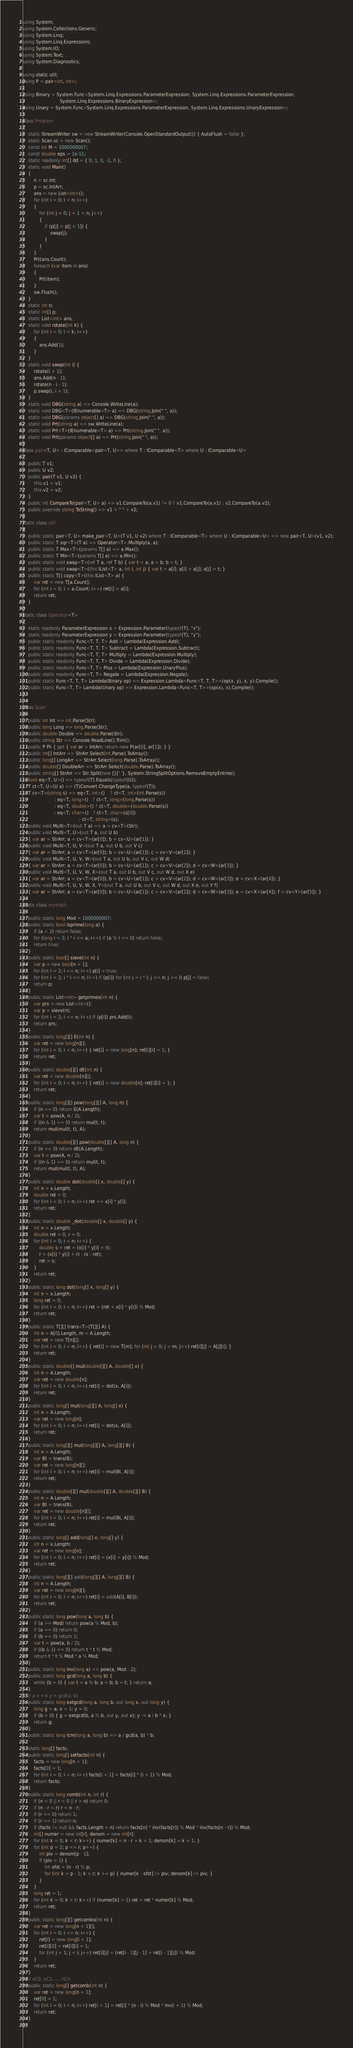Convert code to text. <code><loc_0><loc_0><loc_500><loc_500><_C#_>using System;
using System.Collections.Generic;
using System.Linq;
using System.Linq.Expressions;
using System.IO;
using System.Text;
using System.Diagnostics;

using static util;
using P = pair<int, int>;

using Binary = System.Func<System.Linq.Expressions.ParameterExpression, System.Linq.Expressions.ParameterExpression,
                           System.Linq.Expressions.BinaryExpression>;
using Unary = System.Func<System.Linq.Expressions.ParameterExpression, System.Linq.Expressions.UnaryExpression>;

class Program
{
    static StreamWriter sw = new StreamWriter(Console.OpenStandardOutput()) { AutoFlush = false };
    static Scan sc = new Scan();
    const int M = 1000000007;
    const double eps = 1e-11;
    static readonly int[] dd = { 0, 1, 0, -1, 0 };
    static void Main()
    {
        n = sc.Int;
        p = sc.IntArr;
        ans = new List<int>();
        for (int i = 0; i < n; i++)
        {
            for (int j = 0; j + 1 < n; j++)
            {
                if (p[j] > p[j + 1]) {
                    swap(j);
                }
            }
        }
        Prt(ans.Count);
        foreach (var item in ans)
        {
            Prt(item);
        }
        sw.Flush();
    }
    static int n;
    static int[] p;
    static List<int> ans;
    static void rotate(int k) {
        for (int i = 0; i < k; i++)
        {
            ans.Add(1);
        }
    }
    static void swap(int i) {
        rotate(i + 1);
        ans.Add(n - 1);
        rotate(n - i - 1);
        p.swap(i, i + 1);
    }
    static void DBG(string a) => Console.WriteLine(a);
    static void DBG<T>(IEnumerable<T> a) => DBG(string.Join(" ", a));
    static void DBG(params object[] a) => DBG(string.Join(" ", a));
    static void Prt(string a) => sw.WriteLine(a);
    static void Prt<T>(IEnumerable<T> a) => Prt(string.Join(" ", a));
    static void Prt(params object[] a) => Prt(string.Join(" ", a));
}
class pair<T, U> : IComparable<pair<T, U>> where T : IComparable<T> where U : IComparable<U>
{
    public T v1;
    public U v2;
    public pair(T v1, U v2) {
        this.v1 = v1;
        this.v2 = v2;
    }
    public int CompareTo(pair<T, U> a) => v1.CompareTo(a.v1) != 0 ? v1.CompareTo(a.v1) : v2.CompareTo(a.v2);
    public override string ToString() => v1 + " " + v2;
}
static class util
{
    public static pair<T, U> make_pair<T, U>(T v1, U v2) where T : IComparable<T> where U : IComparable<U> => new pair<T, U>(v1, v2);
    public static T sqr<T>(T a) => Operator<T>.Multiply(a, a);
    public static T Max<T>(params T[] a) => a.Max();
    public static T Min<T>(params T[] a) => a.Min();
    public static void swap<T>(ref T a, ref T b) { var t = a; a = b; b = t; }
    public static void swap<T>(this IList<T> a, int i, int j) { var t = a[i]; a[i] = a[j]; a[j] = t; }
    public static T[] copy<T>(this IList<T> a) {
        var ret = new T[a.Count];
        for (int i = 0; i < a.Count; i++) ret[i] = a[i];
        return ret;
    }
}
static class Operator<T>
{
    static readonly ParameterExpression x = Expression.Parameter(typeof(T), "x");
    static readonly ParameterExpression y = Expression.Parameter(typeof(T), "y");
    public static readonly Func<T, T, T> Add = Lambda(Expression.Add);
    public static readonly Func<T, T, T> Subtract = Lambda(Expression.Subtract);
    public static readonly Func<T, T, T> Multiply = Lambda(Expression.Multiply);
    public static readonly Func<T, T, T> Divide = Lambda(Expression.Divide);
    public static readonly Func<T, T> Plus = Lambda(Expression.UnaryPlus);
    public static readonly Func<T, T> Negate = Lambda(Expression.Negate);
    public static Func<T, T, T> Lambda(Binary op) => Expression.Lambda<Func<T, T, T>>(op(x, y), x, y).Compile();
    public static Func<T, T> Lambda(Unary op) => Expression.Lambda<Func<T, T>>(op(x), x).Compile();
}

class Scan
{
    public int Int => int.Parse(Str);
    public long Long => long.Parse(Str);
    public double Double => double.Parse(Str);
    public string Str => Console.ReadLine().Trim();
    public P Pii { get { var ar = IntArr; return new P(ar[0], ar[1]); } }
    public int[] IntArr => StrArr.Select(int.Parse).ToArray();
    public long[] LongArr => StrArr.Select(long.Parse).ToArray();
    public double[] DoubleArr => StrArr.Select(double.Parse).ToArray();
    public string[] StrArr => Str.Split(new []{' '}, System.StringSplitOptions.RemoveEmptyEntries);
    bool eq<T, U>() => typeof(T).Equals(typeof(U));
    T ct<T, U>(U a) => (T)Convert.ChangeType(a, typeof(T));
    T cv<T>(string s) => eq<T, int>()    ? ct<T, int>(int.Parse(s))
                       : eq<T, long>()   ? ct<T, long>(long.Parse(s))
                       : eq<T, double>() ? ct<T, double>(double.Parse(s))
                       : eq<T, char>()   ? ct<T, char>(s[0])
                                         : ct<T, string>(s);
    public void Multi<T>(out T a) => a = cv<T>(Str);
    public void Multi<T, U>(out T a, out U b)
    { var ar = StrArr; a = cv<T>(ar[0]); b = cv<U>(ar[1]); }
    public void Multi<T, U, V>(out T a, out U b, out V c)
    { var ar = StrArr; a = cv<T>(ar[0]); b = cv<U>(ar[1]); c = cv<V>(ar[2]); }
    public void Multi<T, U, V, W>(out T a, out U b, out V c, out W d)
    { var ar = StrArr; a = cv<T>(ar[0]); b = cv<U>(ar[1]); c = cv<V>(ar[2]); d = cv<W>(ar[3]); }
    public void Multi<T, U, V, W, X>(out T a, out U b, out V c, out W d, out X e)
    { var ar = StrArr; a = cv<T>(ar[0]); b = cv<U>(ar[1]); c = cv<V>(ar[2]); d = cv<W>(ar[3]); e = cv<X>(ar[4]); }
    public void Multi<T, U, V, W, X, Y>(out T a, out U b, out V c, out W d, out X e, out Y f)
    { var ar = StrArr; a = cv<T>(ar[0]); b = cv<U>(ar[1]); c = cv<V>(ar[2]); d = cv<W>(ar[3]); e = cv<X>(ar[4]); f = cv<Y>(ar[5]); }
}
static class mymath
{
    public static long Mod = 1000000007;
    public static bool isprime(long a) {
        if (a < 2) return false;
        for (long i = 2; i * i <= a; i++) if (a % i == 0) return false;
        return true;
    }
    public static bool[] sieve(int n) {
        var p = new bool[n + 1];
        for (int i = 2; i <= n; i++) p[i] = true;
        for (int i = 2; i * i <= n; i++) if (p[i]) for (int j = i * i; j <= n; j += i) p[j] = false;
        return p;
    }
    public static List<int> getprimes(int n) {
        var prs = new List<int>();
        var p = sieve(n);
        for (int i = 2; i <= n; i++) if (p[i]) prs.Add(i);
        return prs;
    }
    public static long[][] E(int n) {
        var ret = new long[n][];
        for (int i = 0; i < n; i++) { ret[i] = new long[n]; ret[i][i] = 1; }
        return ret;
    }
    public static double[][] dE(int n) {
        var ret = new double[n][];
        for (int i = 0; i < n; i++) { ret[i] = new double[n]; ret[i][i] = 1; }
        return ret;
    }
    public static long[][] pow(long[][] A, long n) {
        if (n == 0) return E(A.Length);
        var t = pow(A, n / 2);
        if ((n & 1) == 0) return mul(t, t);
        return mul(mul(t, t), A);
    }
    public static double[][] pow(double[][] A, long n) {
        if (n == 0) return dE(A.Length);
        var t = pow(A, n / 2);
        if ((n & 1) == 0) return mul(t, t);
        return mul(mul(t, t), A);
    }
    public static double dot(double[] x, double[] y) {
        int n = x.Length;
        double ret = 0;
        for (int i = 0; i < n; i++) ret += x[i] * y[i];
        return ret;
    }
    public static double _dot(double[] x, double[] y) {
        int n = x.Length;
        double ret = 0, r = 0;
        for (int i = 0; i < n; i++) {
            double s = ret + (x[i] * y[i] + r);
            r = (x[i] * y[i] + r) - (s - ret);
            ret = s;
        }
        return ret;
    }
    public static long dot(long[] x, long[] y) {
        int n = x.Length;
        long ret = 0;
        for (int i = 0; i < n; i++) ret = (ret + x[i] * y[i]) % Mod;
        return ret;
    }
    public static T[][] trans<T>(T[][] A) {
        int n = A[0].Length, m = A.Length;
        var ret = new T[n][];
        for (int i = 0; i < n; i++) { ret[i] = new T[m]; for (int j = 0; j < m; j++) ret[i][j] = A[j][i]; }
        return ret;
    }
    public static double[] mul(double[][] A, double[] x) {
        int n = A.Length;
        var ret = new double[n];
        for (int i = 0; i < n; i++) ret[i] = dot(x, A[i]);
        return ret;
    }
    public static long[] mul(long[][] A, long[] x) {
        int n = A.Length;
        var ret = new long[n];
        for (int i = 0; i < n; i++) ret[i] = dot(x, A[i]);
        return ret;
    }
    public static long[][] mul(long[][] A, long[][] B) {
        int n = A.Length;
        var Bt = trans(B);
        var ret = new long[n][];
        for (int i = 0; i < n; i++) ret[i] = mul(Bt, A[i]);
        return ret;
    }
    public static double[][] mul(double[][] A, double[][] B) {
        int n = A.Length;
        var Bt = trans(B);
        var ret = new double[n][];
        for (int i = 0; i < n; i++) ret[i] = mul(Bt, A[i]);
        return ret;
    }
    public static long[] add(long[] x, long[] y) {
        int n = x.Length;
        var ret = new long[n];
        for (int i = 0; i < n; i++) ret[i] = (x[i] + y[i]) % Mod;
        return ret;
    }
    public static long[][] add(long[][] A, long[][] B) {
        int n = A.Length;
        var ret = new long[n][];
        for (int i = 0; i < n; i++) ret[i] = add(A[i], B[i]);
        return ret;
    }
    public static long pow(long a, long b) {
        if (a >= Mod) return pow(a % Mod, b);
        if (a == 0) return 0;
        if (b == 0) return 1;
        var t = pow(a, b / 2);
        if ((b & 1) == 0) return t * t % Mod;
        return t * t % Mod * a % Mod;
    }
    public static long inv(long a) => pow(a, Mod - 2);
    public static long gcd(long a, long b) {
        while (b > 0) { var t = a % b; a = b; b = t; } return a;
    }
    // a x + b y = gcd(a, b)
    public static long extgcd(long a, long b, out long x, out long y) {
        long g = a; x = 1; y = 0;
        if (b > 0) { g = extgcd(b, a % b, out y, out x); y -= a / b * x; }
        return g;
    }
    public static long lcm(long a, long b) => a / gcd(a, b) * b;

    static long[] facts;
    public static long[] setfacts(int n) {
        facts = new long[n + 1];
        facts[0] = 1;
        for (int i = 0; i < n; i++) facts[i + 1] = facts[i] * (i + 1) % Mod;
        return facts;
    }
    public static long comb(int n, int r) {
        if (n < 0 || r < 0 || r > n) return 0;
        if (n - r < r) r = n - r;
        if (r == 0) return 1;
        if (r == 1) return n;
        if (facts != null && facts.Length > n) return facts[n] * inv(facts[r]) % Mod * inv(facts[n - r]) % Mod;
        int[] numer = new int[r], denom = new int[r];
        for (int k = 0; k < r; k++) { numer[k] = n - r + k + 1; denom[k] = k + 1; }
        for (int p = 2; p <= r; p++) {
            int piv = denom[p - 1];
            if (piv > 1) {
                int ofst = (n - r) % p;
                for (int k = p - 1; k < r; k += p) { numer[k - ofst] /= piv; denom[k] /= piv; }
            }
        }
        long ret = 1;
        for (int k = 0; k < r; k++) if (numer[k] > 1) ret = ret * numer[k] % Mod;
        return ret;
    }
    public static long[][] getcombs(int n) {
        var ret = new long[n + 1][];
        for (int i = 0; i <= n; i++) {
            ret[i] = new long[i + 1];
            ret[i][0] = ret[i][i] = 1;
            for (int j = 1; j < i; j++) ret[i][j] = (ret[i - 1][j - 1] + ret[i - 1][j]) % Mod;
        }
        return ret;
    }
    // nC0, nC2, ..., nCn
    public static long[] getcomb(int n) {
        var ret = new long[n + 1];
        ret[0] = 1;
        for (int i = 0; i < n; i++) ret[i + 1] = ret[i] * (n - i) % Mod * inv(i + 1) % Mod;
        return ret;
    }
}
</code> 